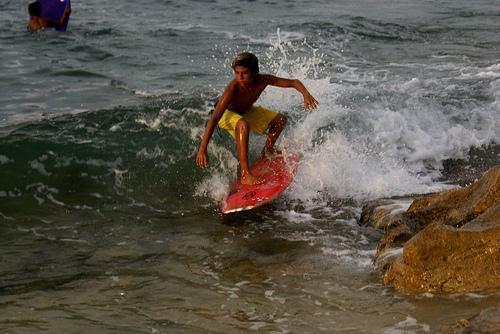How many people surfing?
Give a very brief answer. 1. 